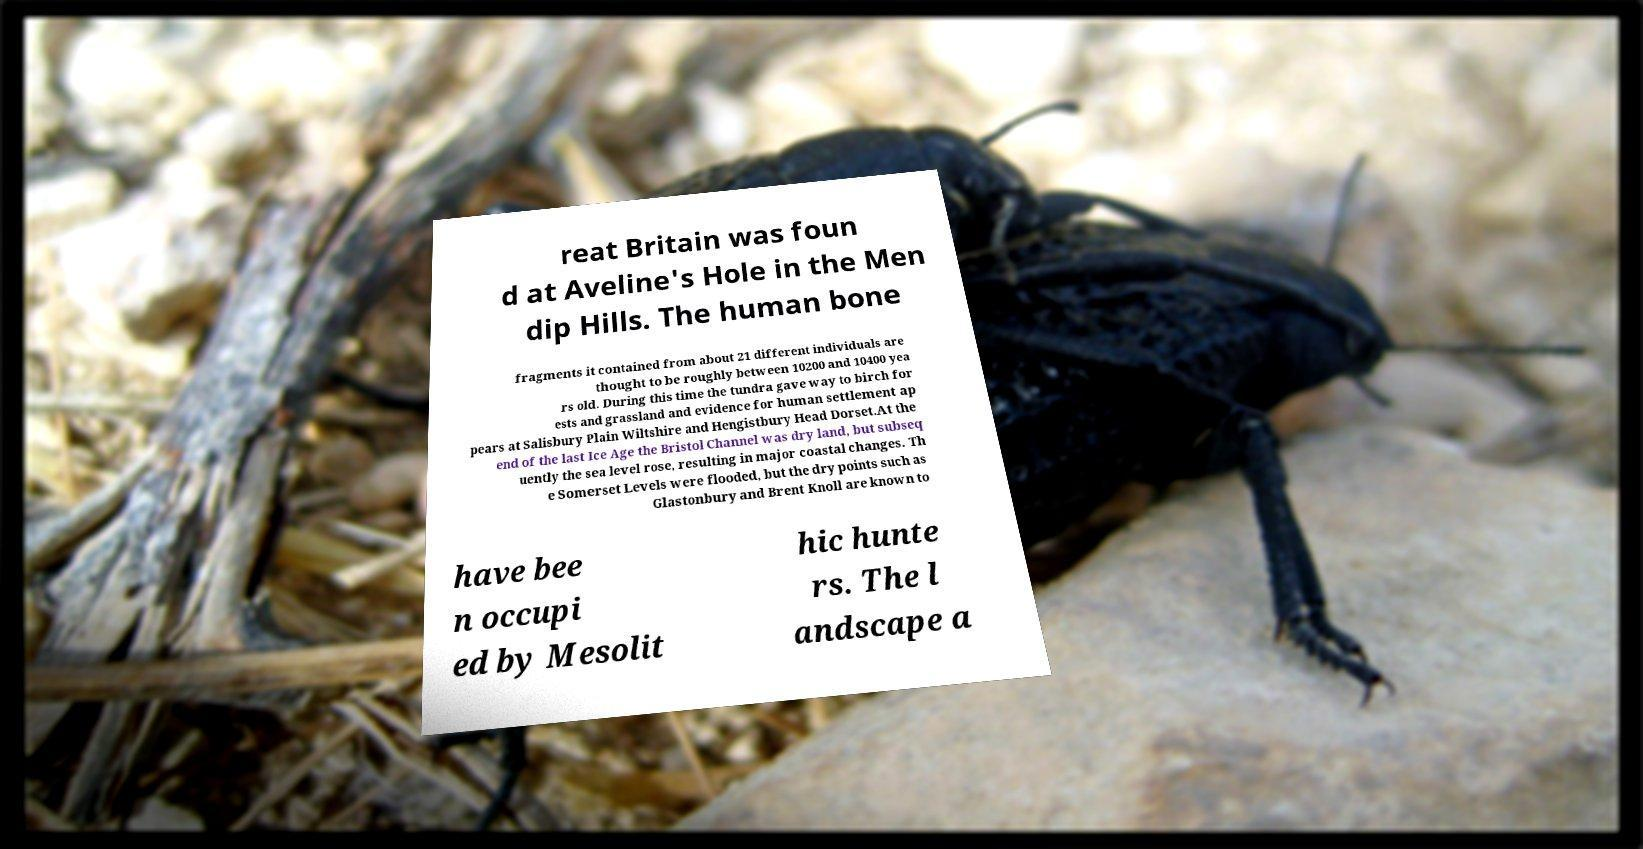Could you extract and type out the text from this image? reat Britain was foun d at Aveline's Hole in the Men dip Hills. The human bone fragments it contained from about 21 different individuals are thought to be roughly between 10200 and 10400 yea rs old. During this time the tundra gave way to birch for ests and grassland and evidence for human settlement ap pears at Salisbury Plain Wiltshire and Hengistbury Head Dorset.At the end of the last Ice Age the Bristol Channel was dry land, but subseq uently the sea level rose, resulting in major coastal changes. Th e Somerset Levels were flooded, but the dry points such as Glastonbury and Brent Knoll are known to have bee n occupi ed by Mesolit hic hunte rs. The l andscape a 